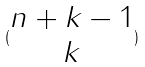Convert formula to latex. <formula><loc_0><loc_0><loc_500><loc_500>( \begin{matrix} n + k - 1 \\ k \end{matrix} )</formula> 